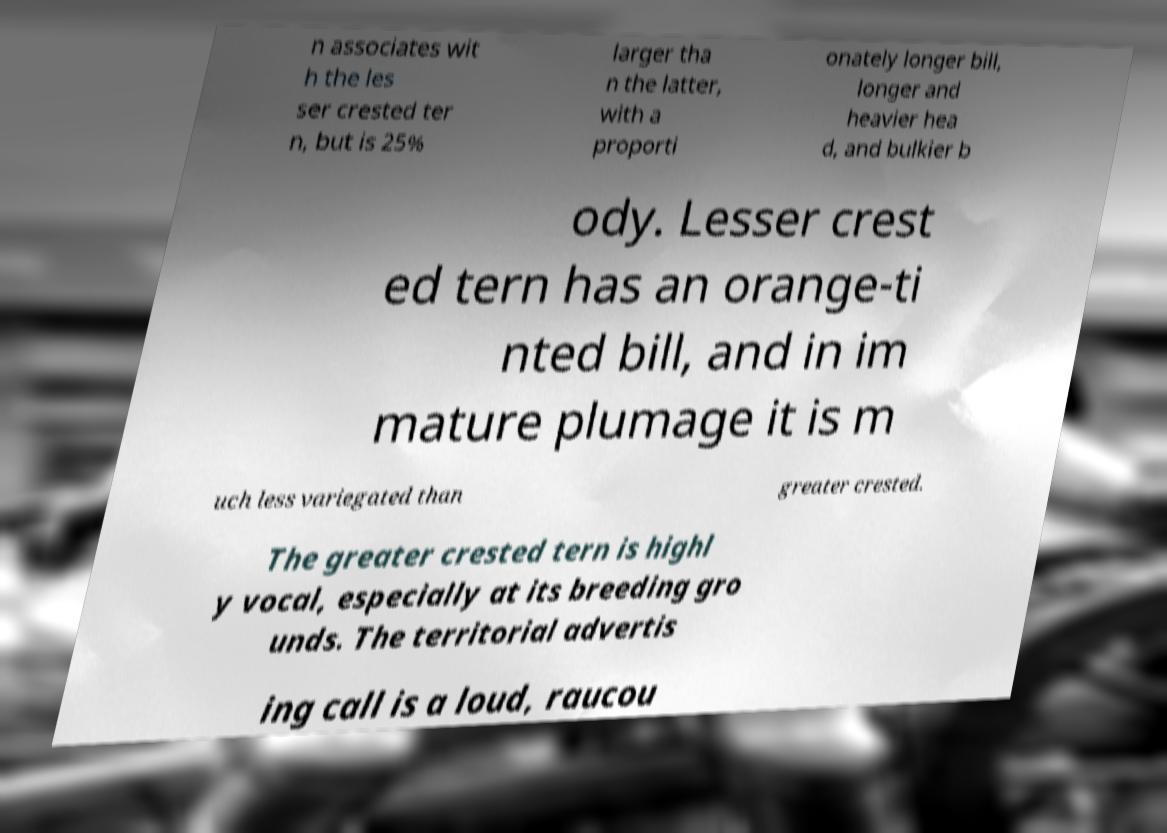What messages or text are displayed in this image? I need them in a readable, typed format. n associates wit h the les ser crested ter n, but is 25% larger tha n the latter, with a proporti onately longer bill, longer and heavier hea d, and bulkier b ody. Lesser crest ed tern has an orange-ti nted bill, and in im mature plumage it is m uch less variegated than greater crested. The greater crested tern is highl y vocal, especially at its breeding gro unds. The territorial advertis ing call is a loud, raucou 